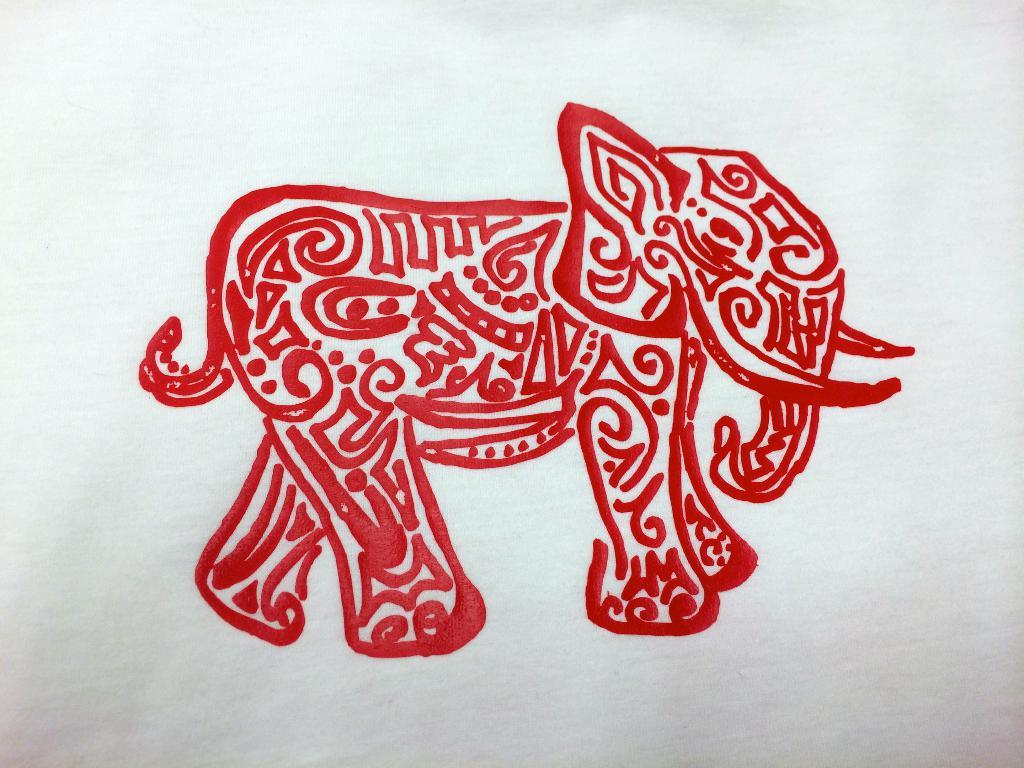What is the main subject of the drawing in the image? There is a drawing of an elephant in the image. What color is the elephant in the drawing? The elephant is colored red. What color is the background of the image? The background of the image is white. What type of silverware is visible in the image? There is no silverware present in the image; it features a drawing of a red elephant on a white background. Is there a rifle depicted in the image? No, there is no rifle present in the image. 